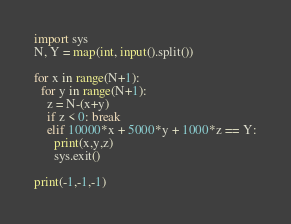Convert code to text. <code><loc_0><loc_0><loc_500><loc_500><_Python_>import sys
N, Y = map(int, input().split())

for x in range(N+1):
  for y in range(N+1):
    z = N-(x+y)
    if z < 0: break
    elif 10000*x + 5000*y + 1000*z == Y:
      print(x,y,z)
      sys.exit()

print(-1,-1,-1)</code> 